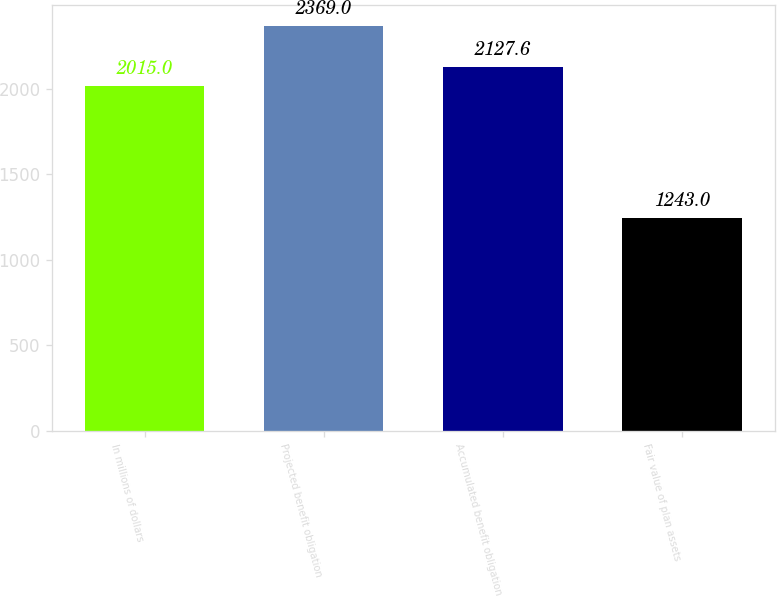Convert chart. <chart><loc_0><loc_0><loc_500><loc_500><bar_chart><fcel>In millions of dollars<fcel>Projected benefit obligation<fcel>Accumulated benefit obligation<fcel>Fair value of plan assets<nl><fcel>2015<fcel>2369<fcel>2127.6<fcel>1243<nl></chart> 